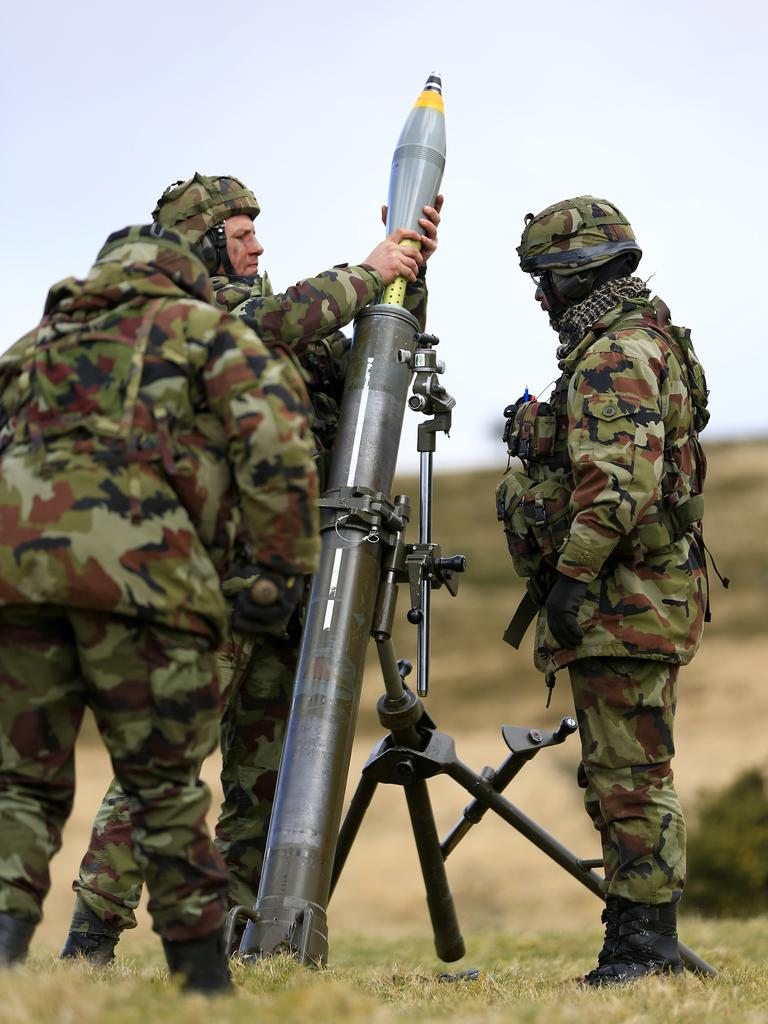How many people are present in the image? There are three people in the image. What are the people wearing? The people are wearing military dress. What object are the people standing around? The people are standing around a rocket. Who is holding the rocket? One person is holding the rocket. What type of terrain is visible in the image? The ground is sand. What is visible in the background of the image? The background is blurred. What part of the natural environment is visible in the image? The sky is visible in the image. What type of rod can be seen in the hands of the person holding the rocket? There is no rod present in the image; the person is holding a rocket. Can you tell me how many tickets are visible in the image? There are no tickets present in the image. 